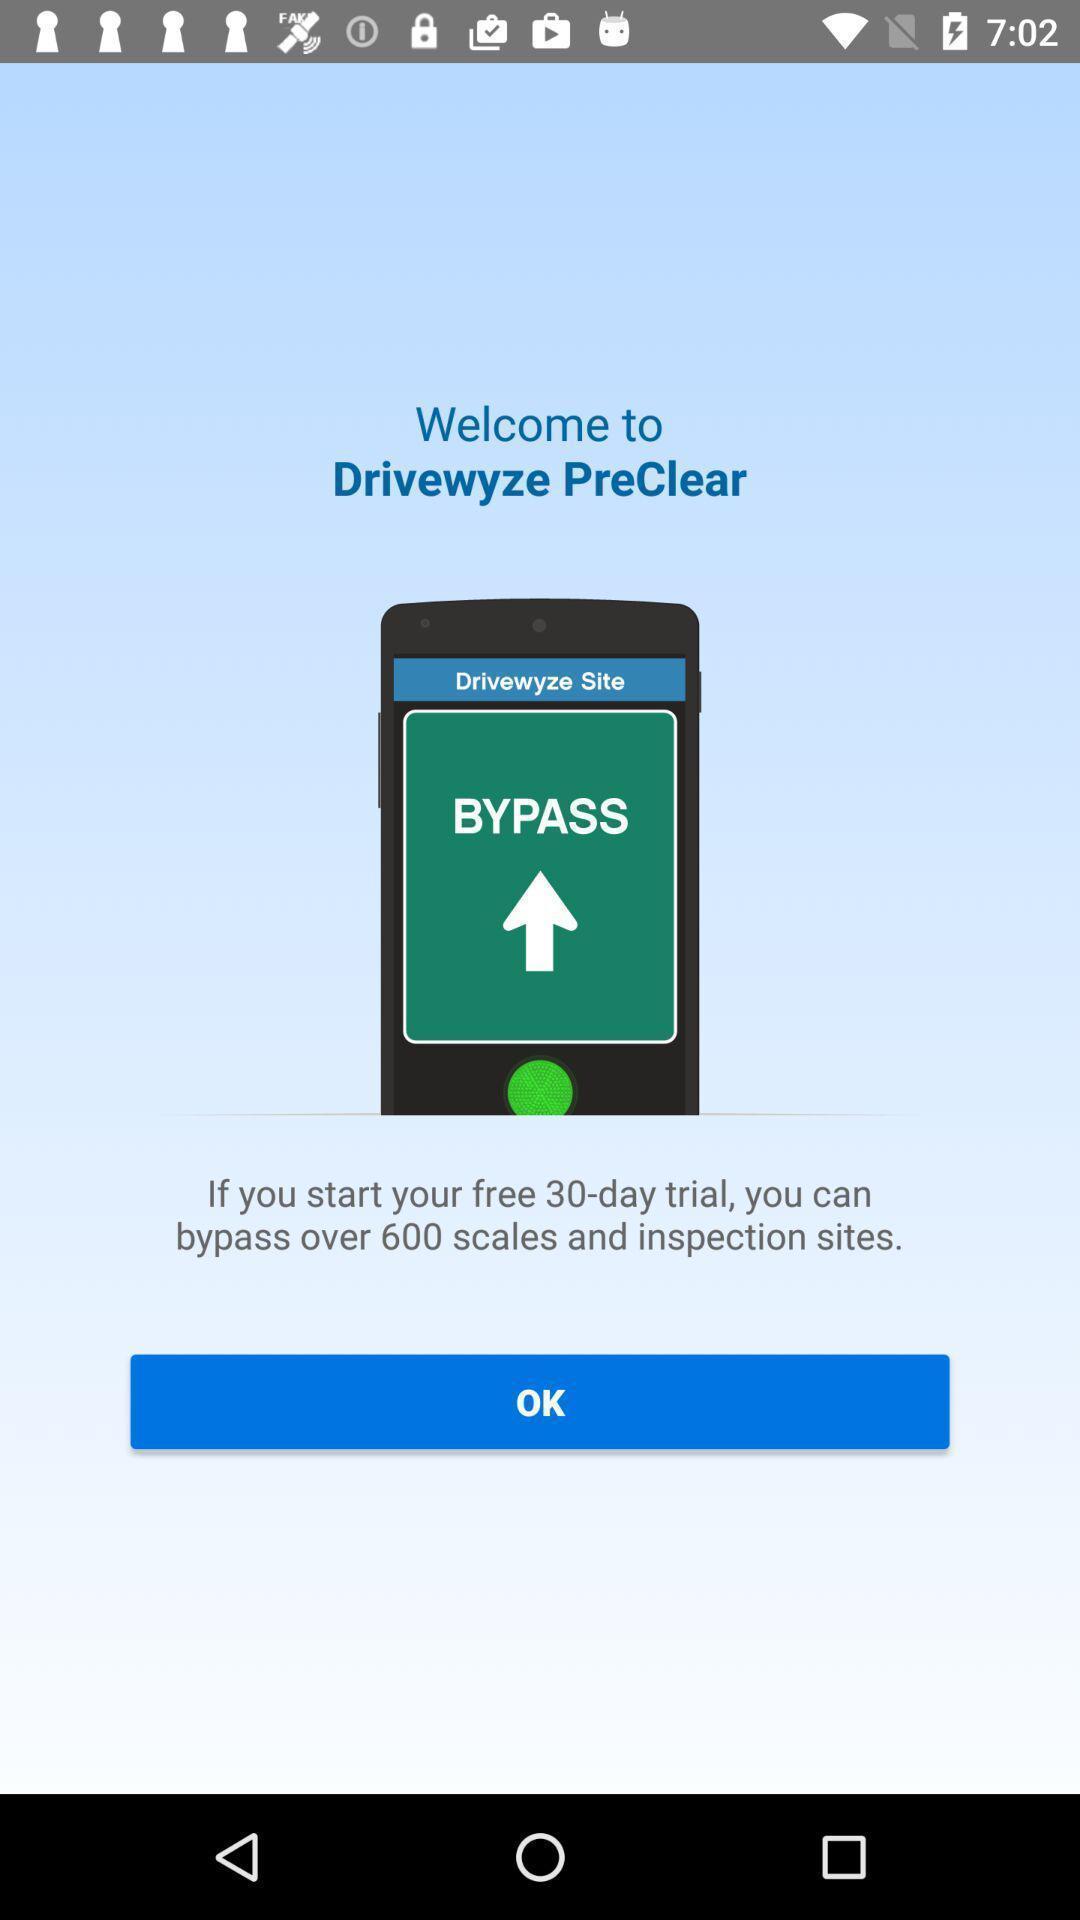Provide a textual representation of this image. Welcome page to the application. 